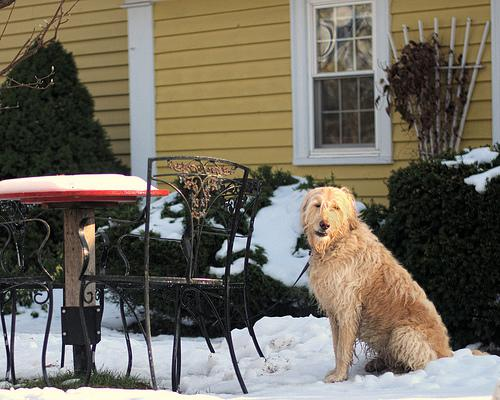Question: why is ground white?
Choices:
A. Sand.
B. Snow.
C. It snowed.
D. Residue.
Answer with the letter. Answer: C Question: what is this?
Choices:
A. Cow.
B. Pig.
C. Goat.
D. A house.
Answer with the letter. Answer: D Question: when was picture taken?
Choices:
A. Morning.
B. Evening.
C. During daylight.
D. Afternoon.
Answer with the letter. Answer: C Question: what is dog doing?
Choices:
A. Running.
B. Sleeping.
C. Sitting.
D. Playing.
Answer with the letter. Answer: C Question: where is table?
Choices:
A. Left of living room.
B. Right of living room.
C. To left of dog.
D. Corner.
Answer with the letter. Answer: C 